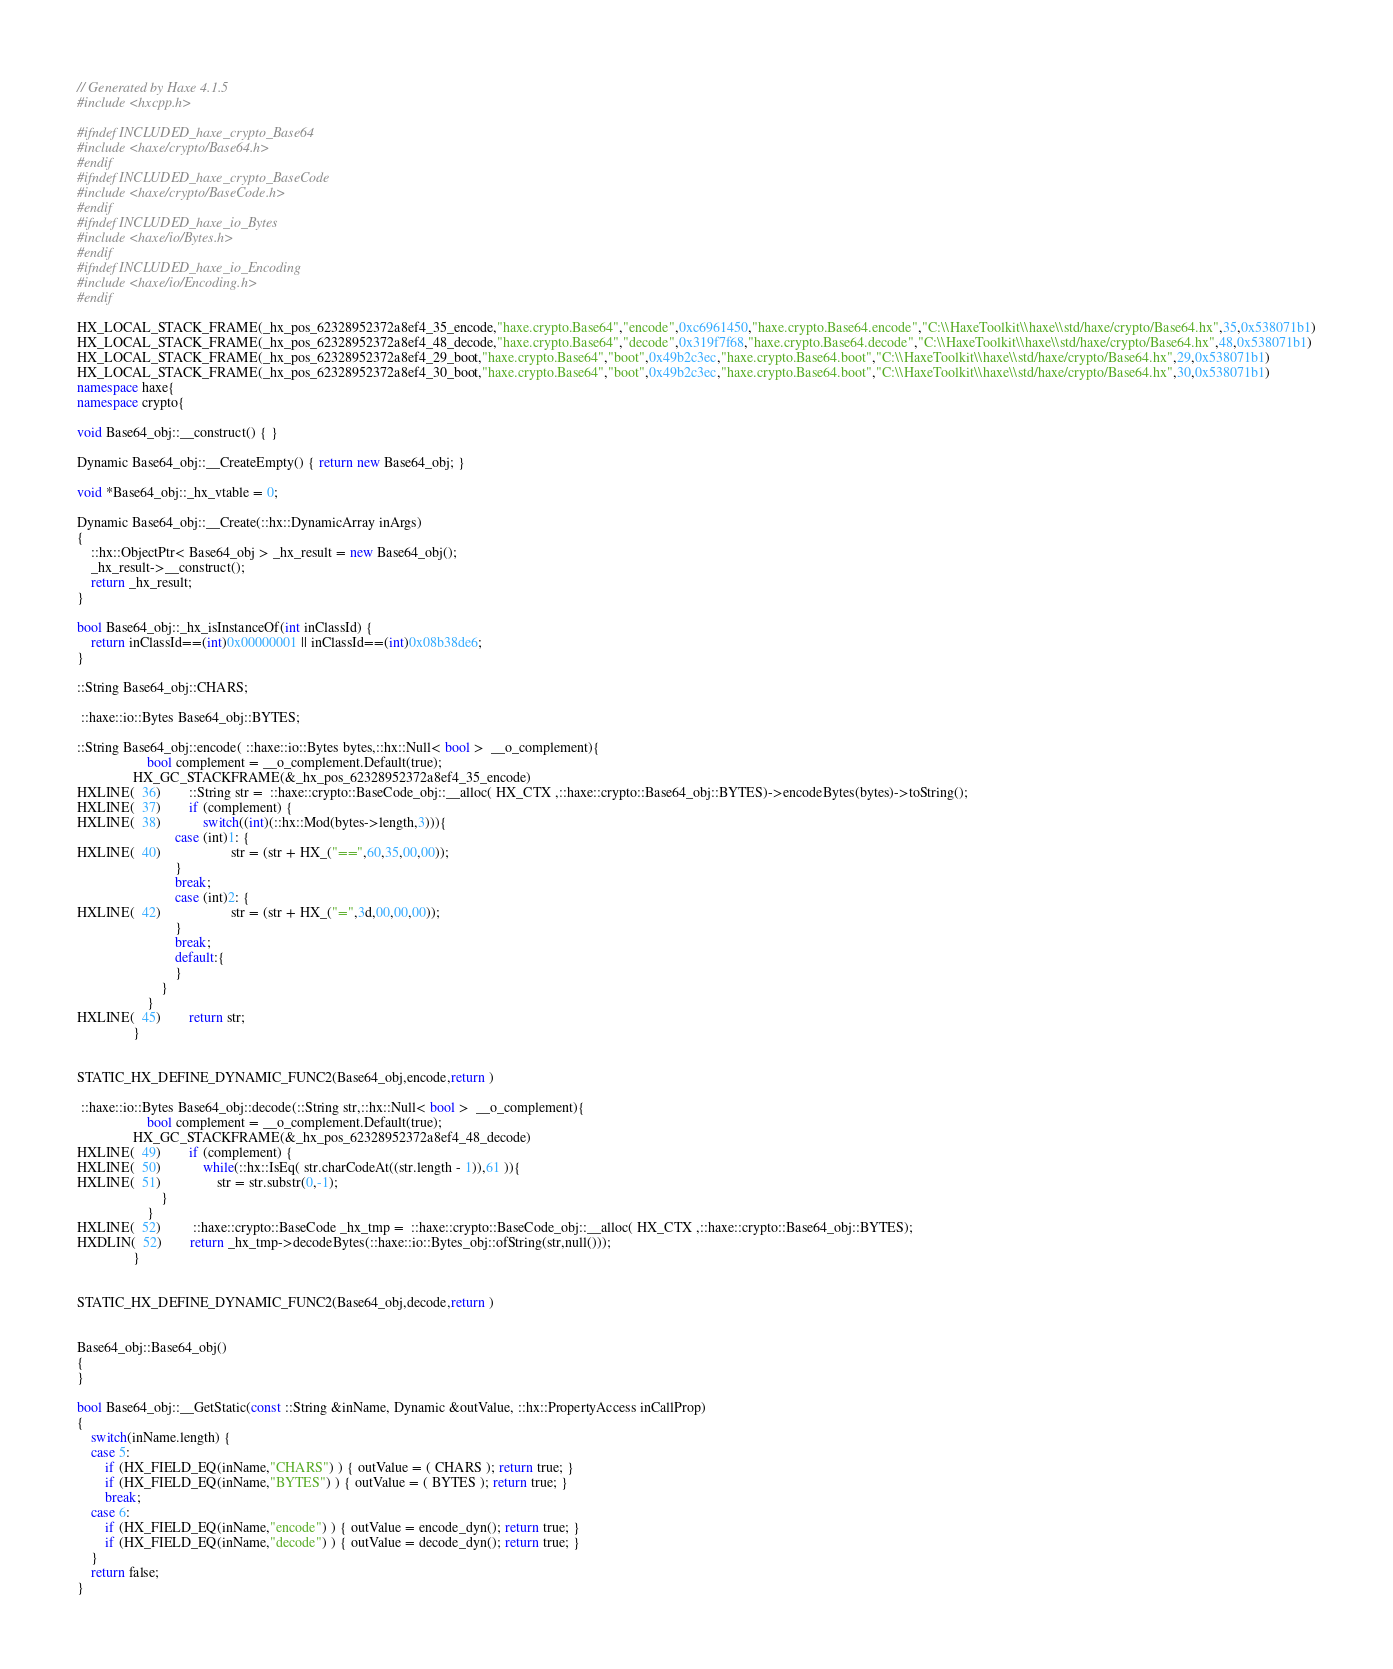<code> <loc_0><loc_0><loc_500><loc_500><_C++_>// Generated by Haxe 4.1.5
#include <hxcpp.h>

#ifndef INCLUDED_haxe_crypto_Base64
#include <haxe/crypto/Base64.h>
#endif
#ifndef INCLUDED_haxe_crypto_BaseCode
#include <haxe/crypto/BaseCode.h>
#endif
#ifndef INCLUDED_haxe_io_Bytes
#include <haxe/io/Bytes.h>
#endif
#ifndef INCLUDED_haxe_io_Encoding
#include <haxe/io/Encoding.h>
#endif

HX_LOCAL_STACK_FRAME(_hx_pos_62328952372a8ef4_35_encode,"haxe.crypto.Base64","encode",0xc6961450,"haxe.crypto.Base64.encode","C:\\HaxeToolkit\\haxe\\std/haxe/crypto/Base64.hx",35,0x538071b1)
HX_LOCAL_STACK_FRAME(_hx_pos_62328952372a8ef4_48_decode,"haxe.crypto.Base64","decode",0x319f7f68,"haxe.crypto.Base64.decode","C:\\HaxeToolkit\\haxe\\std/haxe/crypto/Base64.hx",48,0x538071b1)
HX_LOCAL_STACK_FRAME(_hx_pos_62328952372a8ef4_29_boot,"haxe.crypto.Base64","boot",0x49b2c3ec,"haxe.crypto.Base64.boot","C:\\HaxeToolkit\\haxe\\std/haxe/crypto/Base64.hx",29,0x538071b1)
HX_LOCAL_STACK_FRAME(_hx_pos_62328952372a8ef4_30_boot,"haxe.crypto.Base64","boot",0x49b2c3ec,"haxe.crypto.Base64.boot","C:\\HaxeToolkit\\haxe\\std/haxe/crypto/Base64.hx",30,0x538071b1)
namespace haxe{
namespace crypto{

void Base64_obj::__construct() { }

Dynamic Base64_obj::__CreateEmpty() { return new Base64_obj; }

void *Base64_obj::_hx_vtable = 0;

Dynamic Base64_obj::__Create(::hx::DynamicArray inArgs)
{
	::hx::ObjectPtr< Base64_obj > _hx_result = new Base64_obj();
	_hx_result->__construct();
	return _hx_result;
}

bool Base64_obj::_hx_isInstanceOf(int inClassId) {
	return inClassId==(int)0x00000001 || inClassId==(int)0x08b38de6;
}

::String Base64_obj::CHARS;

 ::haxe::io::Bytes Base64_obj::BYTES;

::String Base64_obj::encode( ::haxe::io::Bytes bytes,::hx::Null< bool >  __o_complement){
            		bool complement = __o_complement.Default(true);
            	HX_GC_STACKFRAME(&_hx_pos_62328952372a8ef4_35_encode)
HXLINE(  36)		::String str =  ::haxe::crypto::BaseCode_obj::__alloc( HX_CTX ,::haxe::crypto::Base64_obj::BYTES)->encodeBytes(bytes)->toString();
HXLINE(  37)		if (complement) {
HXLINE(  38)			switch((int)(::hx::Mod(bytes->length,3))){
            				case (int)1: {
HXLINE(  40)					str = (str + HX_("==",60,35,00,00));
            				}
            				break;
            				case (int)2: {
HXLINE(  42)					str = (str + HX_("=",3d,00,00,00));
            				}
            				break;
            				default:{
            				}
            			}
            		}
HXLINE(  45)		return str;
            	}


STATIC_HX_DEFINE_DYNAMIC_FUNC2(Base64_obj,encode,return )

 ::haxe::io::Bytes Base64_obj::decode(::String str,::hx::Null< bool >  __o_complement){
            		bool complement = __o_complement.Default(true);
            	HX_GC_STACKFRAME(&_hx_pos_62328952372a8ef4_48_decode)
HXLINE(  49)		if (complement) {
HXLINE(  50)			while(::hx::IsEq( str.charCodeAt((str.length - 1)),61 )){
HXLINE(  51)				str = str.substr(0,-1);
            			}
            		}
HXLINE(  52)		 ::haxe::crypto::BaseCode _hx_tmp =  ::haxe::crypto::BaseCode_obj::__alloc( HX_CTX ,::haxe::crypto::Base64_obj::BYTES);
HXDLIN(  52)		return _hx_tmp->decodeBytes(::haxe::io::Bytes_obj::ofString(str,null()));
            	}


STATIC_HX_DEFINE_DYNAMIC_FUNC2(Base64_obj,decode,return )


Base64_obj::Base64_obj()
{
}

bool Base64_obj::__GetStatic(const ::String &inName, Dynamic &outValue, ::hx::PropertyAccess inCallProp)
{
	switch(inName.length) {
	case 5:
		if (HX_FIELD_EQ(inName,"CHARS") ) { outValue = ( CHARS ); return true; }
		if (HX_FIELD_EQ(inName,"BYTES") ) { outValue = ( BYTES ); return true; }
		break;
	case 6:
		if (HX_FIELD_EQ(inName,"encode") ) { outValue = encode_dyn(); return true; }
		if (HX_FIELD_EQ(inName,"decode") ) { outValue = decode_dyn(); return true; }
	}
	return false;
}
</code> 